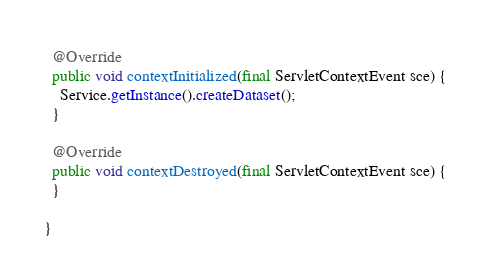<code> <loc_0><loc_0><loc_500><loc_500><_Java_>  @Override
  public void contextInitialized(final ServletContextEvent sce) {
    Service.getInstance().createDataset();
  }

  @Override
  public void contextDestroyed(final ServletContextEvent sce) {
  }

}
</code> 